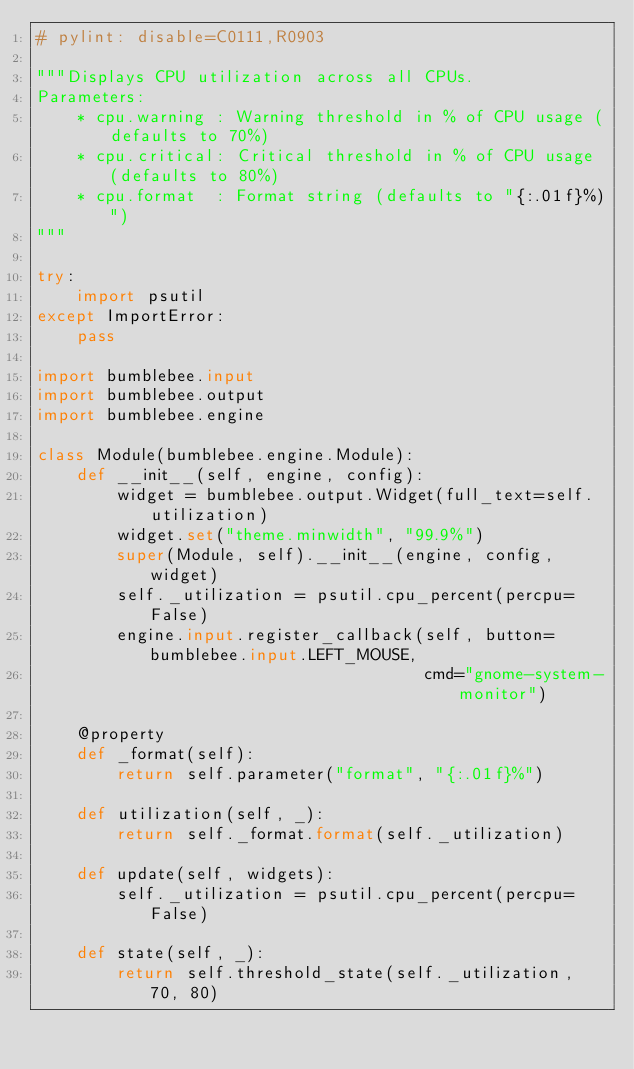<code> <loc_0><loc_0><loc_500><loc_500><_Python_># pylint: disable=C0111,R0903

"""Displays CPU utilization across all CPUs.
Parameters:
    * cpu.warning : Warning threshold in % of CPU usage (defaults to 70%)
    * cpu.critical: Critical threshold in % of CPU usage (defaults to 80%)
    * cpu.format  : Format string (defaults to "{:.01f}%)")
"""

try:
    import psutil
except ImportError:
    pass

import bumblebee.input
import bumblebee.output
import bumblebee.engine

class Module(bumblebee.engine.Module):
    def __init__(self, engine, config):
        widget = bumblebee.output.Widget(full_text=self.utilization)
        widget.set("theme.minwidth", "99.9%")
        super(Module, self).__init__(engine, config, widget)
        self._utilization = psutil.cpu_percent(percpu=False)
        engine.input.register_callback(self, button=bumblebee.input.LEFT_MOUSE,
                                       cmd="gnome-system-monitor")

    @property
    def _format(self):
        return self.parameter("format", "{:.01f}%")

    def utilization(self, _):
        return self._format.format(self._utilization)

    def update(self, widgets):
        self._utilization = psutil.cpu_percent(percpu=False)

    def state(self, _):
        return self.threshold_state(self._utilization, 70, 80)
</code> 